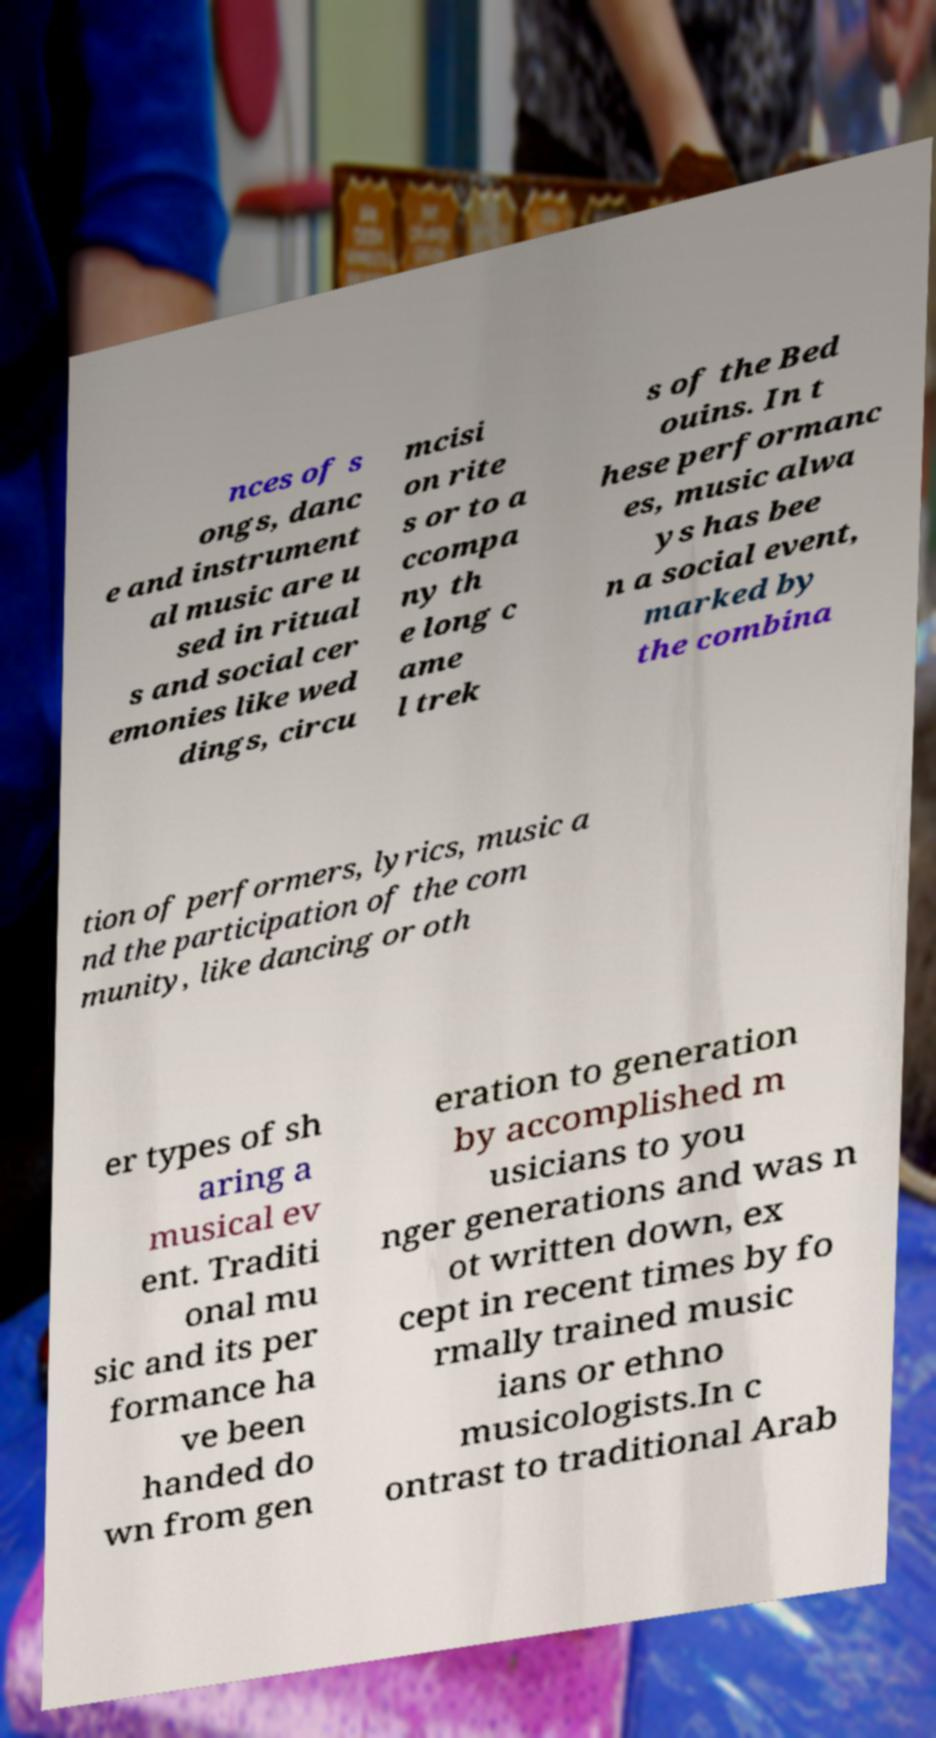Please read and relay the text visible in this image. What does it say? nces of s ongs, danc e and instrument al music are u sed in ritual s and social cer emonies like wed dings, circu mcisi on rite s or to a ccompa ny th e long c ame l trek s of the Bed ouins. In t hese performanc es, music alwa ys has bee n a social event, marked by the combina tion of performers, lyrics, music a nd the participation of the com munity, like dancing or oth er types of sh aring a musical ev ent. Traditi onal mu sic and its per formance ha ve been handed do wn from gen eration to generation by accomplished m usicians to you nger generations and was n ot written down, ex cept in recent times by fo rmally trained music ians or ethno musicologists.In c ontrast to traditional Arab 